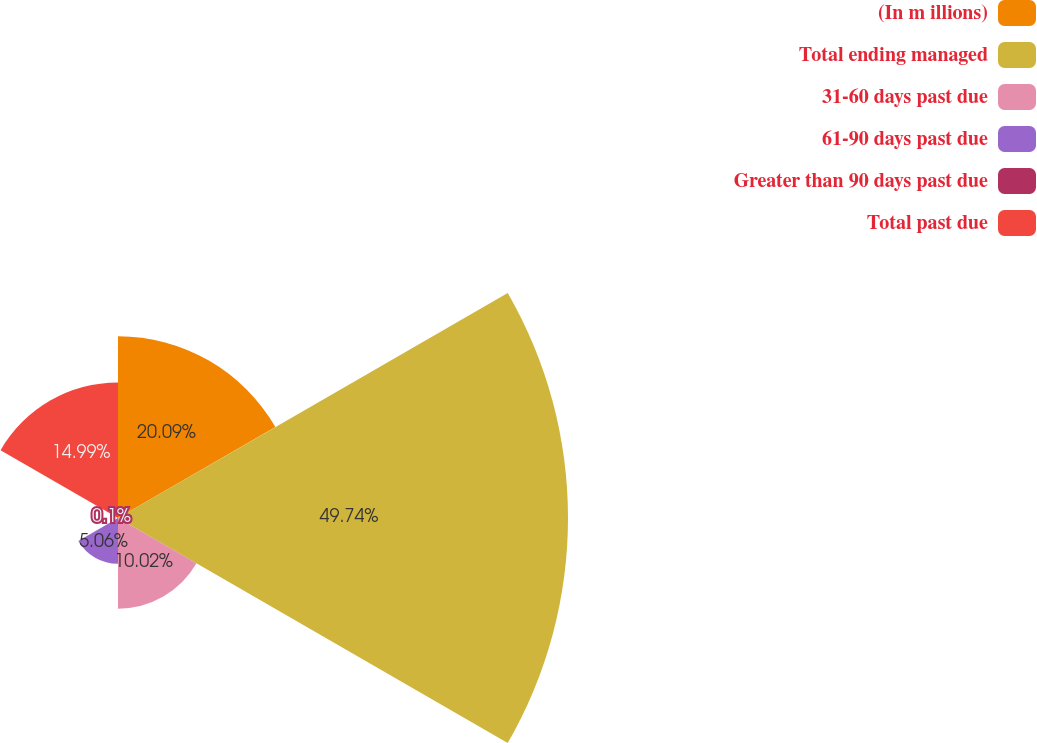Convert chart. <chart><loc_0><loc_0><loc_500><loc_500><pie_chart><fcel>(In m illions)<fcel>Total ending managed<fcel>31-60 days past due<fcel>61-90 days past due<fcel>Greater than 90 days past due<fcel>Total past due<nl><fcel>20.09%<fcel>49.74%<fcel>10.02%<fcel>5.06%<fcel>0.1%<fcel>14.99%<nl></chart> 